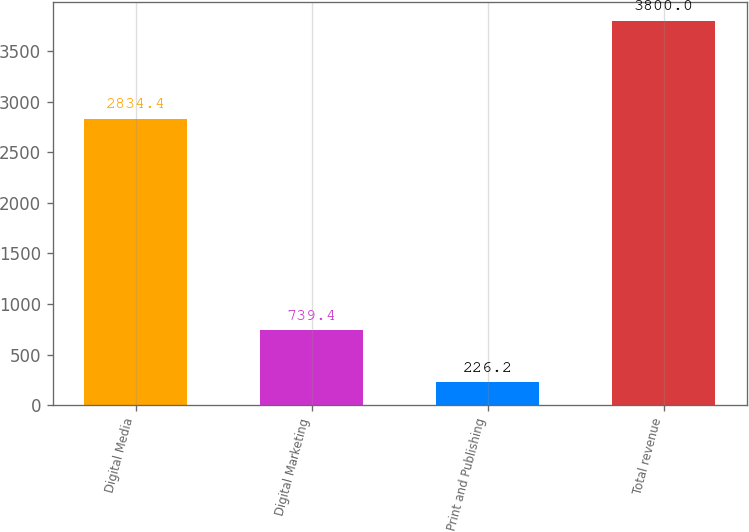<chart> <loc_0><loc_0><loc_500><loc_500><bar_chart><fcel>Digital Media<fcel>Digital Marketing<fcel>Print and Publishing<fcel>Total revenue<nl><fcel>2834.4<fcel>739.4<fcel>226.2<fcel>3800<nl></chart> 